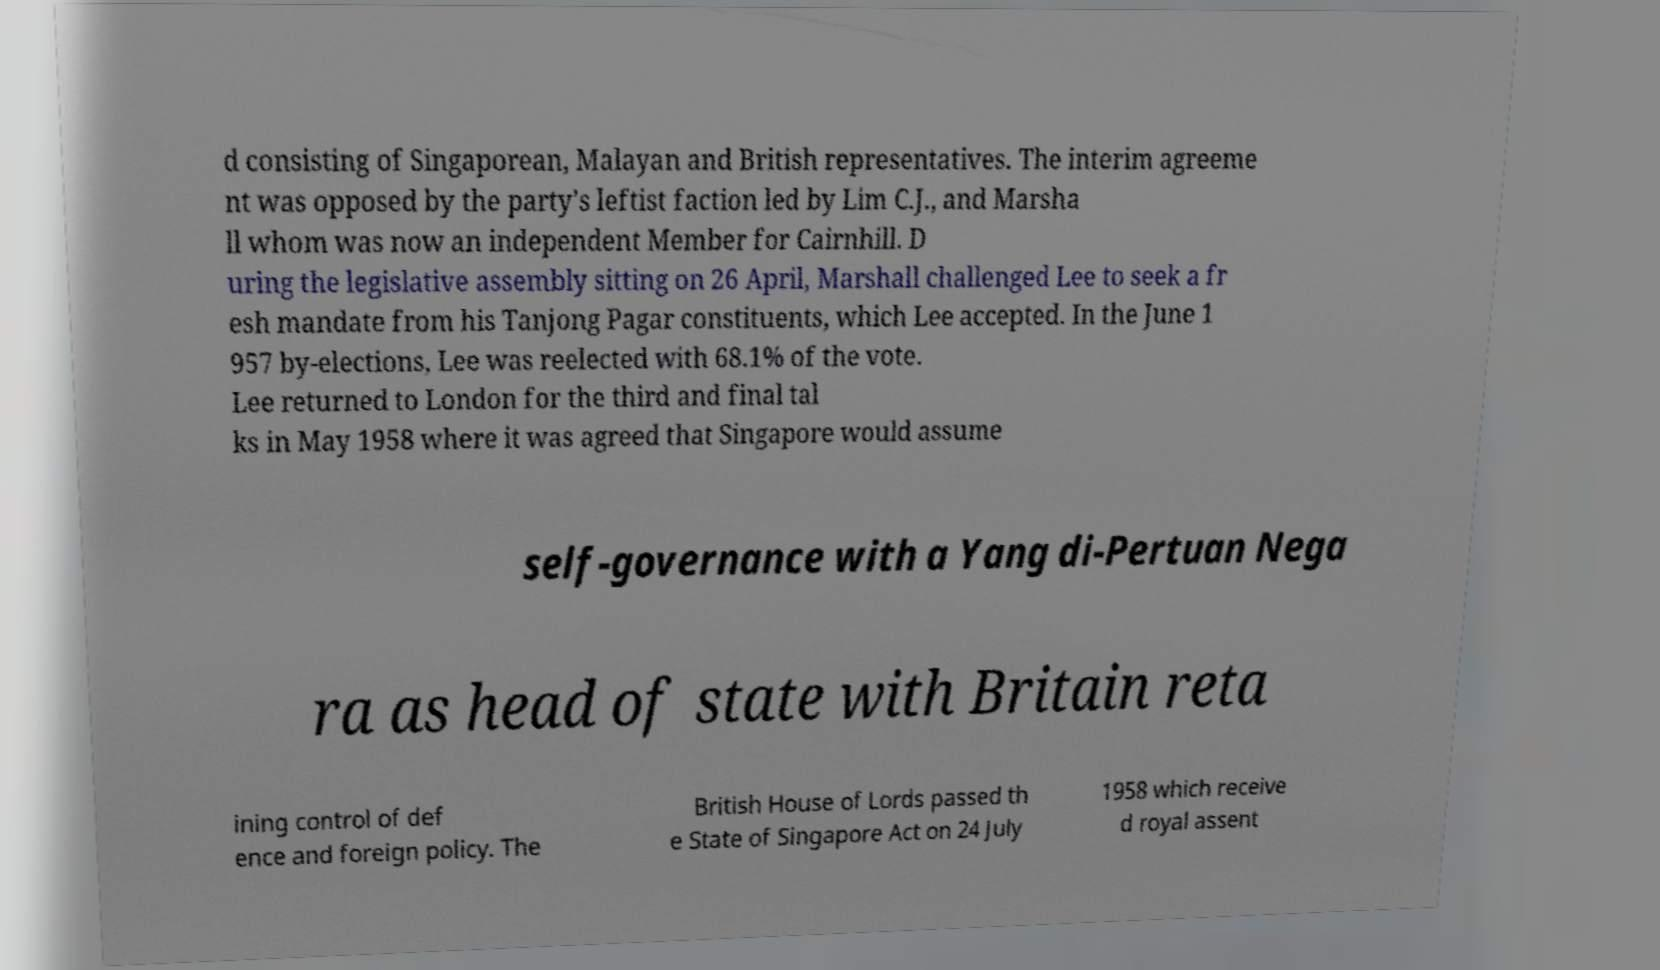Please read and relay the text visible in this image. What does it say? d consisting of Singaporean, Malayan and British representatives. The interim agreeme nt was opposed by the party's leftist faction led by Lim C.J., and Marsha ll whom was now an independent Member for Cairnhill. D uring the legislative assembly sitting on 26 April, Marshall challenged Lee to seek a fr esh mandate from his Tanjong Pagar constituents, which Lee accepted. In the June 1 957 by-elections, Lee was reelected with 68.1% of the vote. Lee returned to London for the third and final tal ks in May 1958 where it was agreed that Singapore would assume self-governance with a Yang di-Pertuan Nega ra as head of state with Britain reta ining control of def ence and foreign policy. The British House of Lords passed th e State of Singapore Act on 24 July 1958 which receive d royal assent 